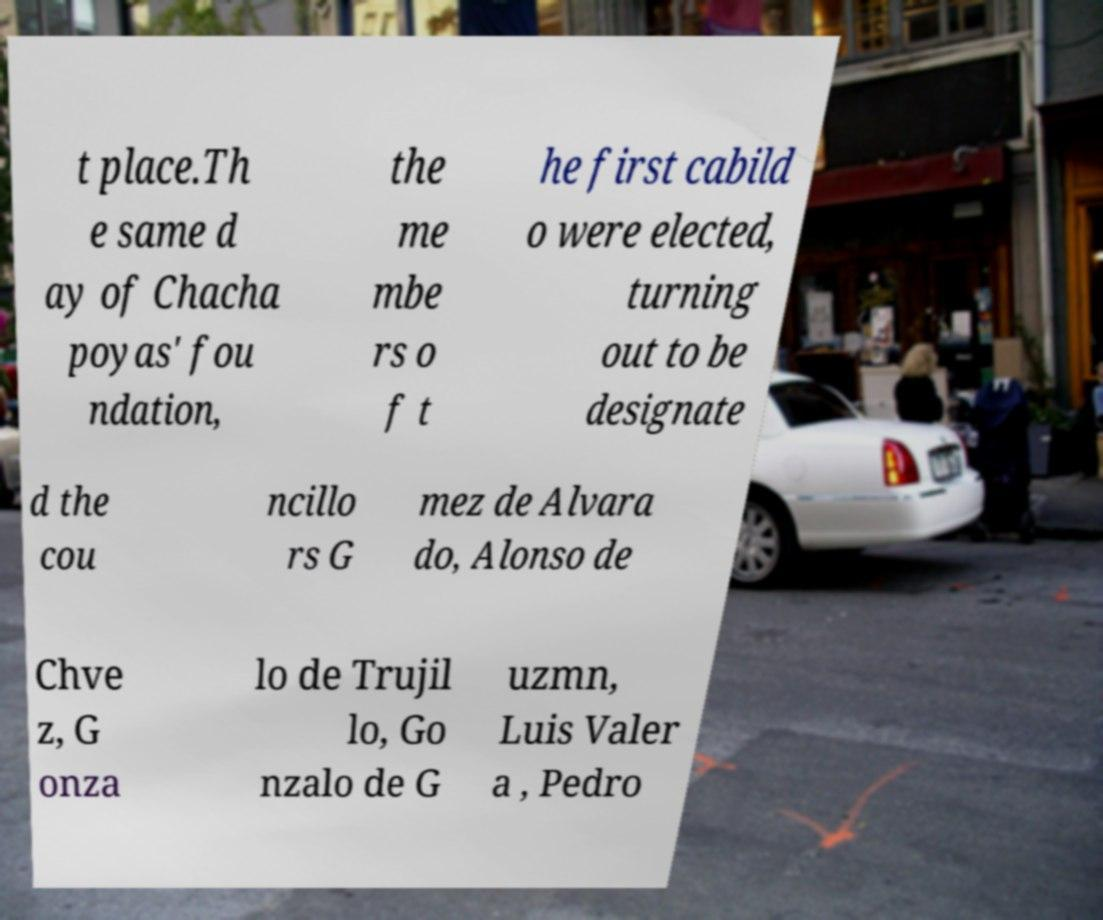There's text embedded in this image that I need extracted. Can you transcribe it verbatim? t place.Th e same d ay of Chacha poyas' fou ndation, the me mbe rs o f t he first cabild o were elected, turning out to be designate d the cou ncillo rs G mez de Alvara do, Alonso de Chve z, G onza lo de Trujil lo, Go nzalo de G uzmn, Luis Valer a , Pedro 